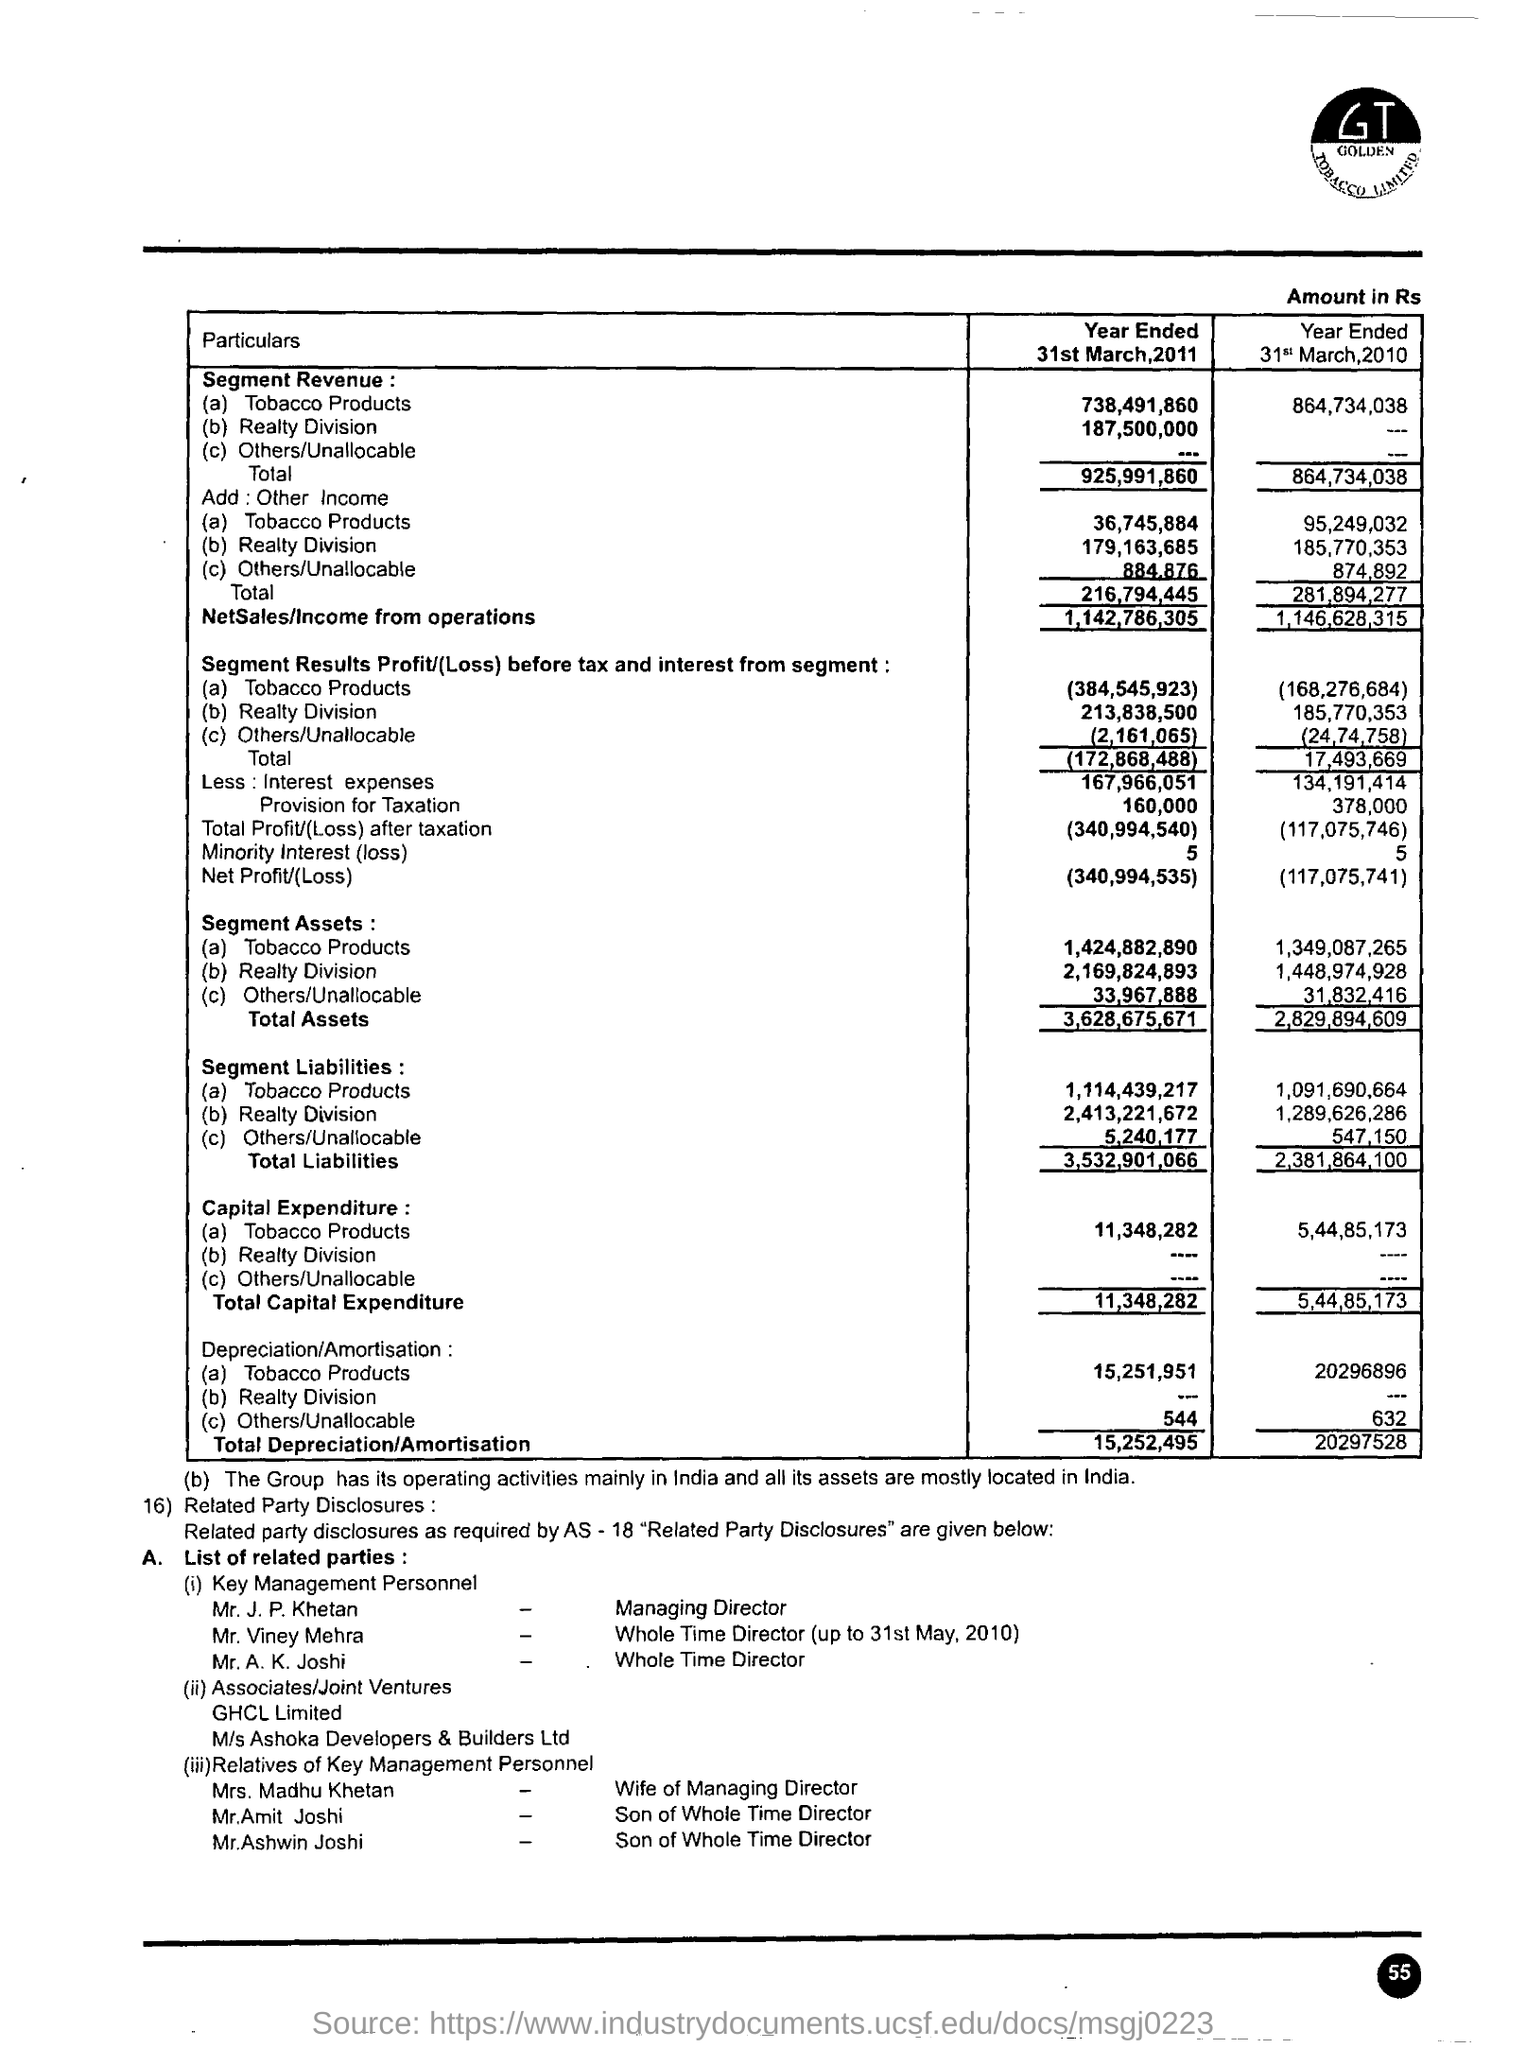What is the NetSales/Income from operations for Year ended 31st March, 2011?
Ensure brevity in your answer.  1,142,786,305. What is the NetSales/Income from operations for Year ended 31st March, 2010?
Make the answer very short. 1,146,628,315. What is the Total Depreciation/Amortisation for Year ended 31st March, 2011?
Keep it short and to the point. 15,252,495. What is the Total Depreciation/Amortisation for Year ended 31st March, 2010?
Your response must be concise. 20297528. What is the Total Capital Expenditure for Year ended 31st March, 2011?
Your answer should be compact. 11,348,282. What is the Total Capital Expenditure for Year ended 31st March, 2010?
Provide a succinct answer. 5,44,85,173. Who is the Managing Director?
Ensure brevity in your answer.  Mr. J. P. Khetan. Who is the Whole time Director?
Your answer should be very brief. Mr. A. K. Joshi. Who is the Whole time Director(up to 31st May, 2010?
Your answer should be very brief. Mr. Viney Mehra. Who is the Wife of Managing Director?
Your answer should be compact. Mrs. Madhu Khetan. 